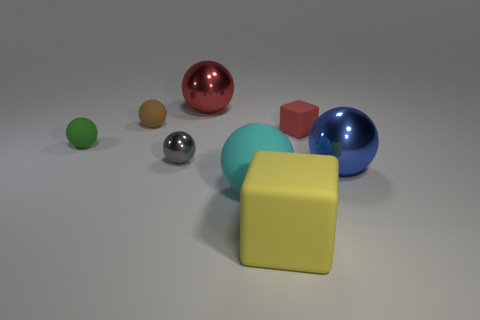There is a red object that is the same shape as the tiny brown rubber object; what size is it? The red object appears to be considerably larger in size compared to the tiny brown rubber object, although they share the same spherical shape. 